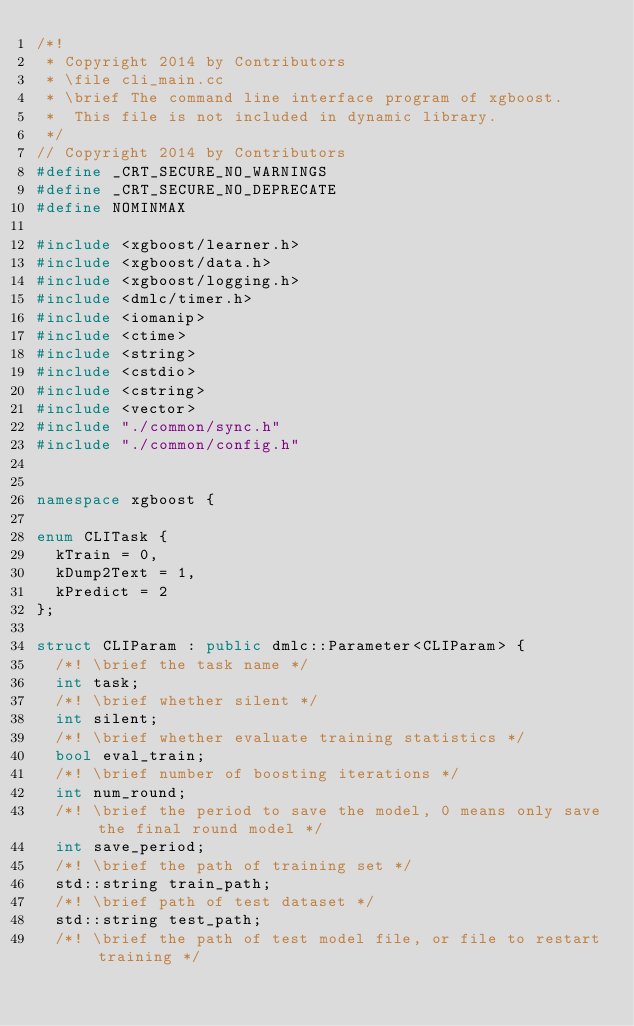<code> <loc_0><loc_0><loc_500><loc_500><_C++_>/*!
 * Copyright 2014 by Contributors
 * \file cli_main.cc
 * \brief The command line interface program of xgboost.
 *  This file is not included in dynamic library.
 */
// Copyright 2014 by Contributors
#define _CRT_SECURE_NO_WARNINGS
#define _CRT_SECURE_NO_DEPRECATE
#define NOMINMAX

#include <xgboost/learner.h>
#include <xgboost/data.h>
#include <xgboost/logging.h>
#include <dmlc/timer.h>
#include <iomanip>
#include <ctime>
#include <string>
#include <cstdio>
#include <cstring>
#include <vector>
#include "./common/sync.h"
#include "./common/config.h"


namespace xgboost {

enum CLITask {
  kTrain = 0,
  kDump2Text = 1,
  kPredict = 2
};

struct CLIParam : public dmlc::Parameter<CLIParam> {
  /*! \brief the task name */
  int task;
  /*! \brief whether silent */
  int silent;
  /*! \brief whether evaluate training statistics */
  bool eval_train;
  /*! \brief number of boosting iterations */
  int num_round;
  /*! \brief the period to save the model, 0 means only save the final round model */
  int save_period;
  /*! \brief the path of training set */
  std::string train_path;
  /*! \brief path of test dataset */
  std::string test_path;
  /*! \brief the path of test model file, or file to restart training */</code> 